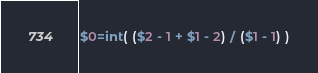<code> <loc_0><loc_0><loc_500><loc_500><_Awk_>$0=int( ($2 - 1 + $1 - 2) / ($1 - 1) )</code> 